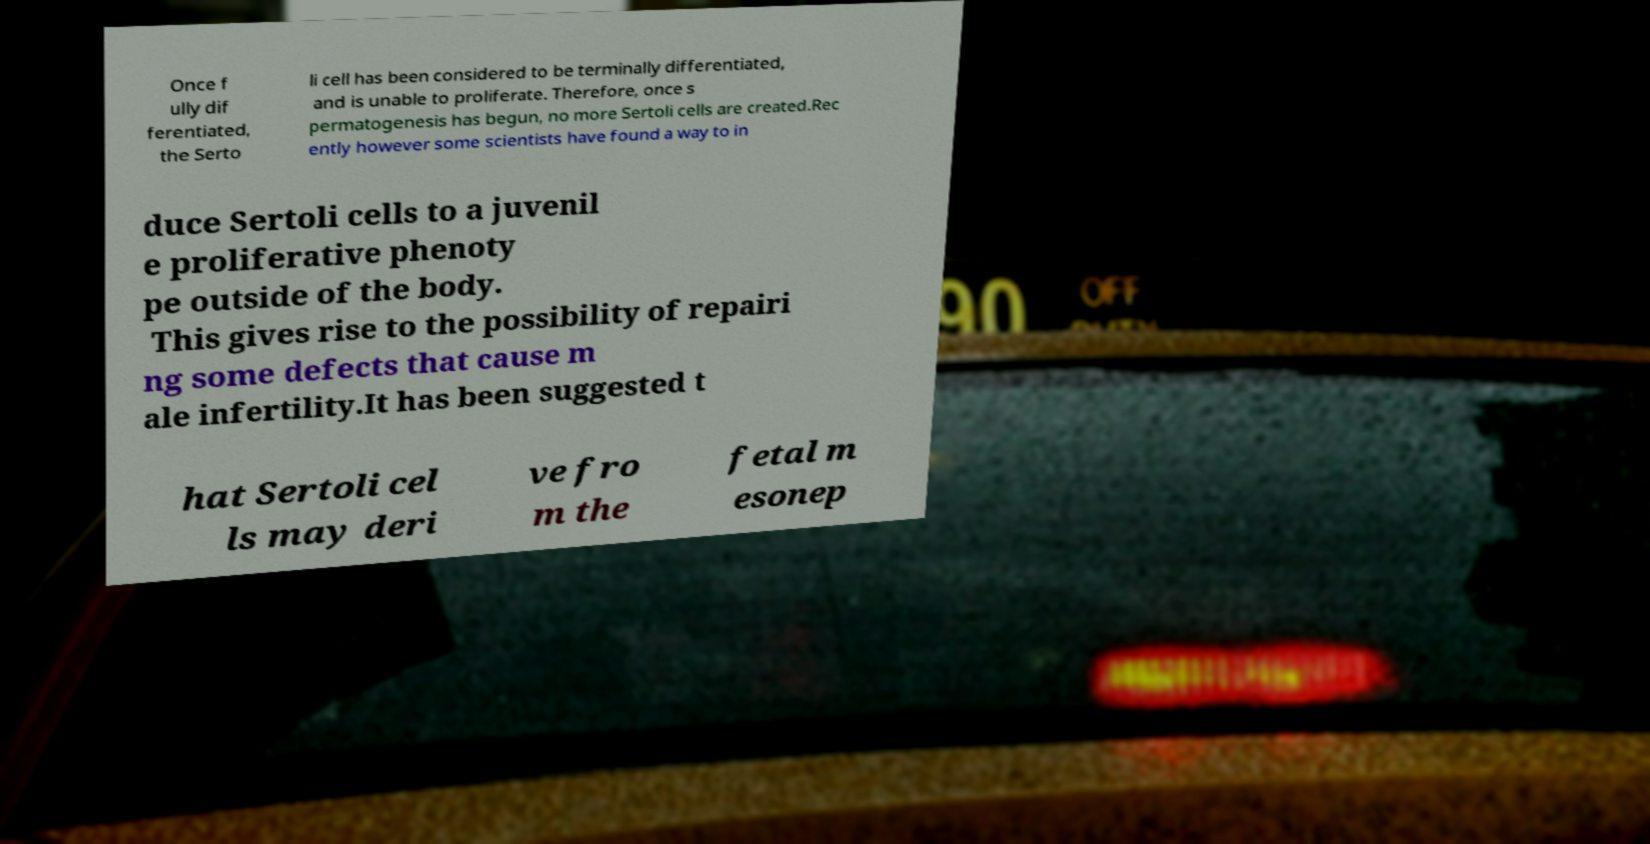Can you read and provide the text displayed in the image?This photo seems to have some interesting text. Can you extract and type it out for me? Once f ully dif ferentiated, the Serto li cell has been considered to be terminally differentiated, and is unable to proliferate. Therefore, once s permatogenesis has begun, no more Sertoli cells are created.Rec ently however some scientists have found a way to in duce Sertoli cells to a juvenil e proliferative phenoty pe outside of the body. This gives rise to the possibility of repairi ng some defects that cause m ale infertility.It has been suggested t hat Sertoli cel ls may deri ve fro m the fetal m esonep 